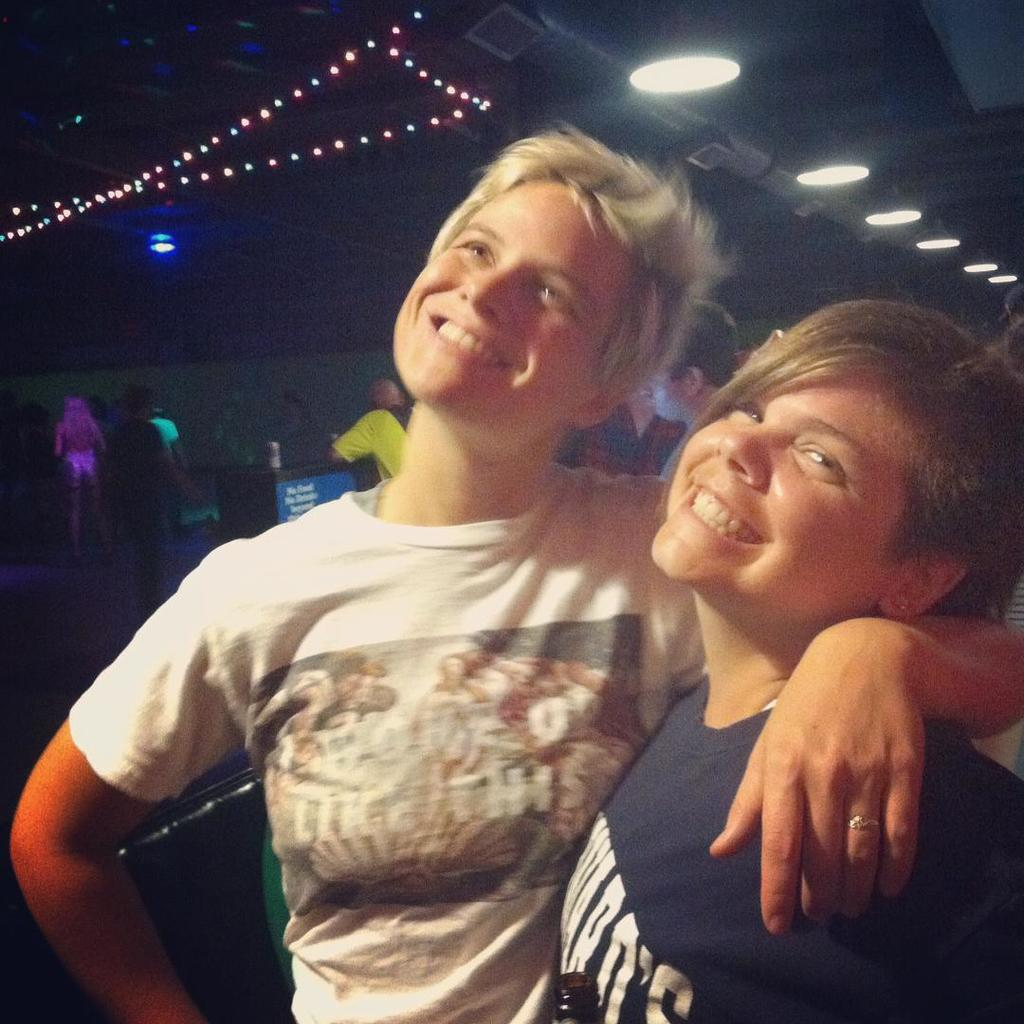How many people are present in the image? There are two persons in the image. What is the facial expression of the two persons? The two persons are smiling. Can you describe the setting of the image? There are many people in the background of the image. What can be seen on the ceiling in the image? There are lights on the ceiling in the image. What type of car is parked in front of the two persons in the image? There is no car present in the image; it only features the two persons and the background with many people. 